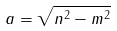Convert formula to latex. <formula><loc_0><loc_0><loc_500><loc_500>a = \sqrt { n ^ { 2 } - m ^ { 2 } }</formula> 